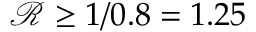<formula> <loc_0><loc_0><loc_500><loc_500>\mathcal { R } \geq 1 / 0 . 8 = 1 . 2 5</formula> 